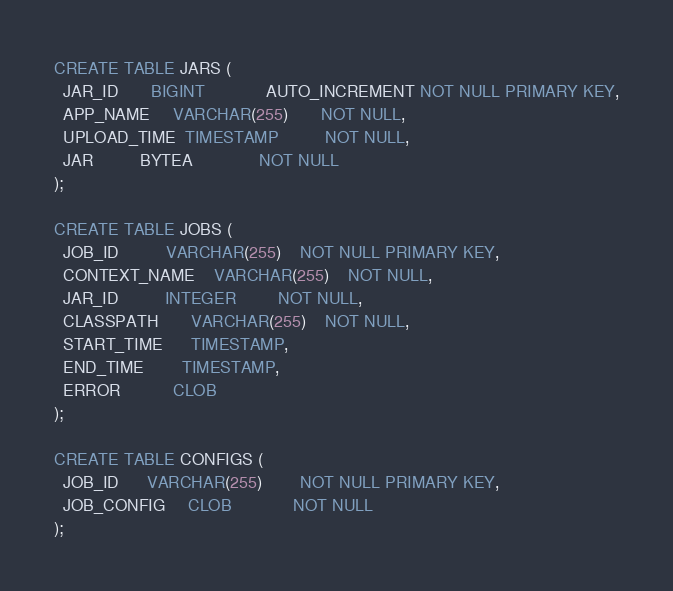Convert code to text. <code><loc_0><loc_0><loc_500><loc_500><_SQL_>CREATE TABLE JARS (
  JAR_ID       BIGINT             AUTO_INCREMENT NOT NULL PRIMARY KEY,
  APP_NAME     VARCHAR(255)       NOT NULL,
  UPLOAD_TIME  TIMESTAMP          NOT NULL,
  JAR          BYTEA              NOT NULL
);

CREATE TABLE JOBS (
  JOB_ID          VARCHAR(255)    NOT NULL PRIMARY KEY,
  CONTEXT_NAME    VARCHAR(255)    NOT NULL,
  JAR_ID          INTEGER         NOT NULL,
  CLASSPATH       VARCHAR(255)    NOT NULL,
  START_TIME      TIMESTAMP,
  END_TIME        TIMESTAMP,
  ERROR           CLOB
);

CREATE TABLE CONFIGS (
  JOB_ID      VARCHAR(255)        NOT NULL PRIMARY KEY,
  JOB_CONFIG     CLOB             NOT NULL
);
</code> 